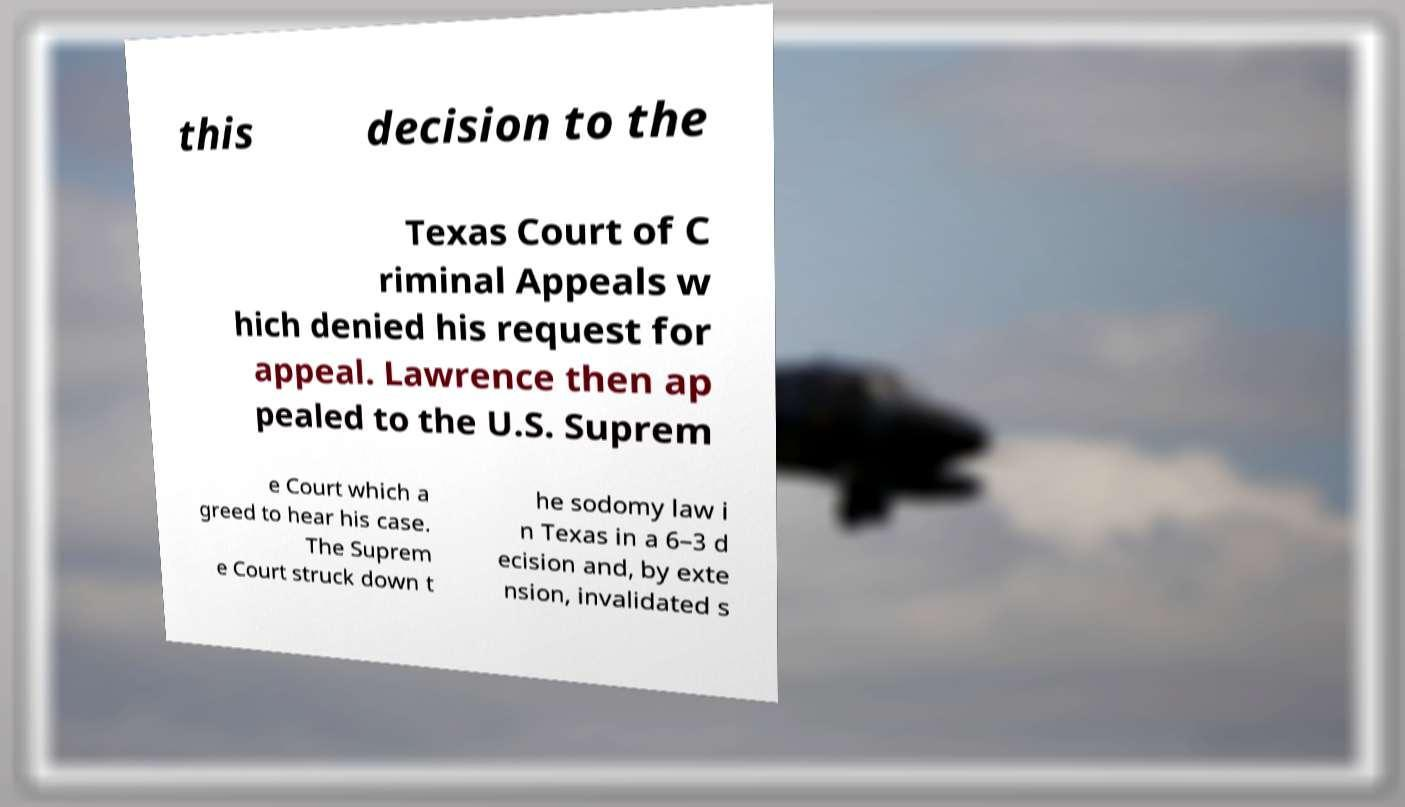There's text embedded in this image that I need extracted. Can you transcribe it verbatim? this decision to the Texas Court of C riminal Appeals w hich denied his request for appeal. Lawrence then ap pealed to the U.S. Suprem e Court which a greed to hear his case. The Suprem e Court struck down t he sodomy law i n Texas in a 6–3 d ecision and, by exte nsion, invalidated s 